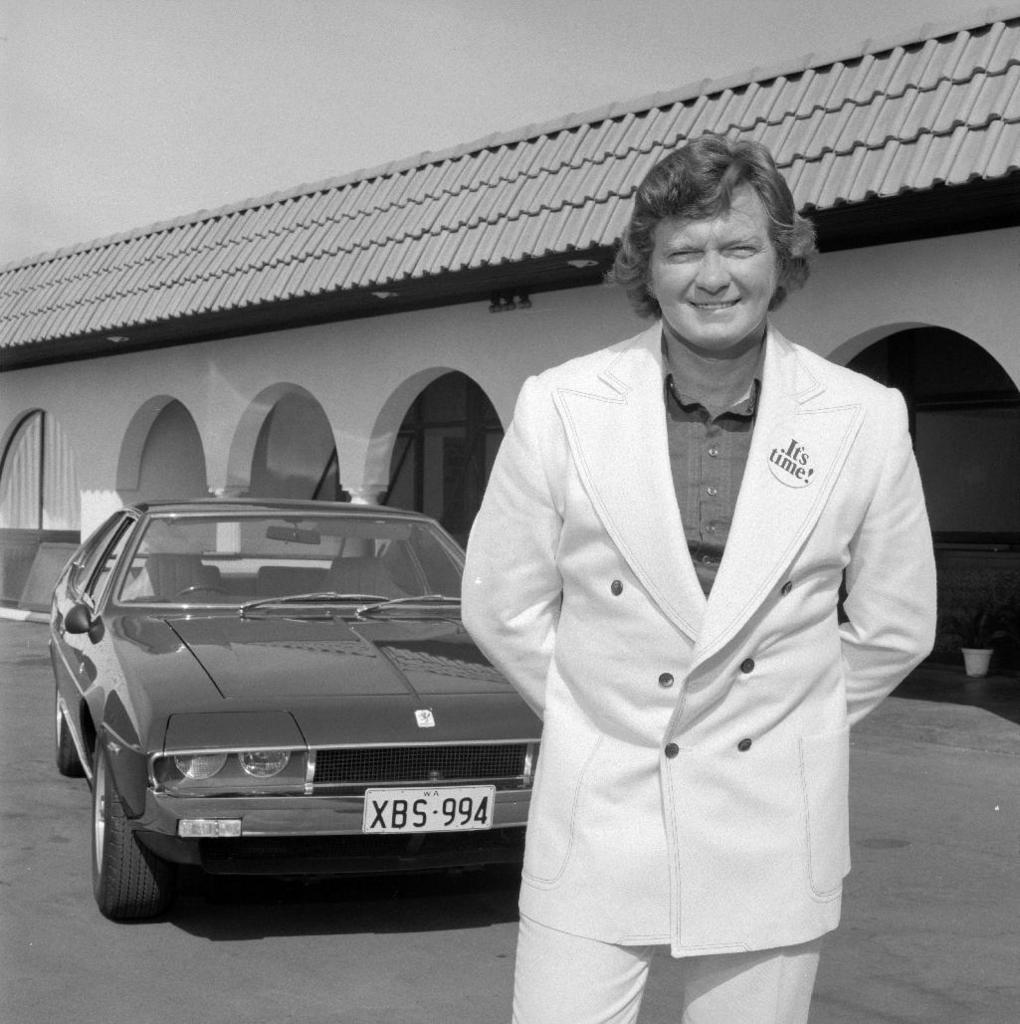What is the main subject of the image? There is a person standing in the image. What else can be seen in the image besides the person? There is a car and a building visible in the image. What is visible at the top of the image? The sky is visible at the top of the image. What is the name of the thing that the person is holding in the image? There is no thing visible in the image that the person is holding. 